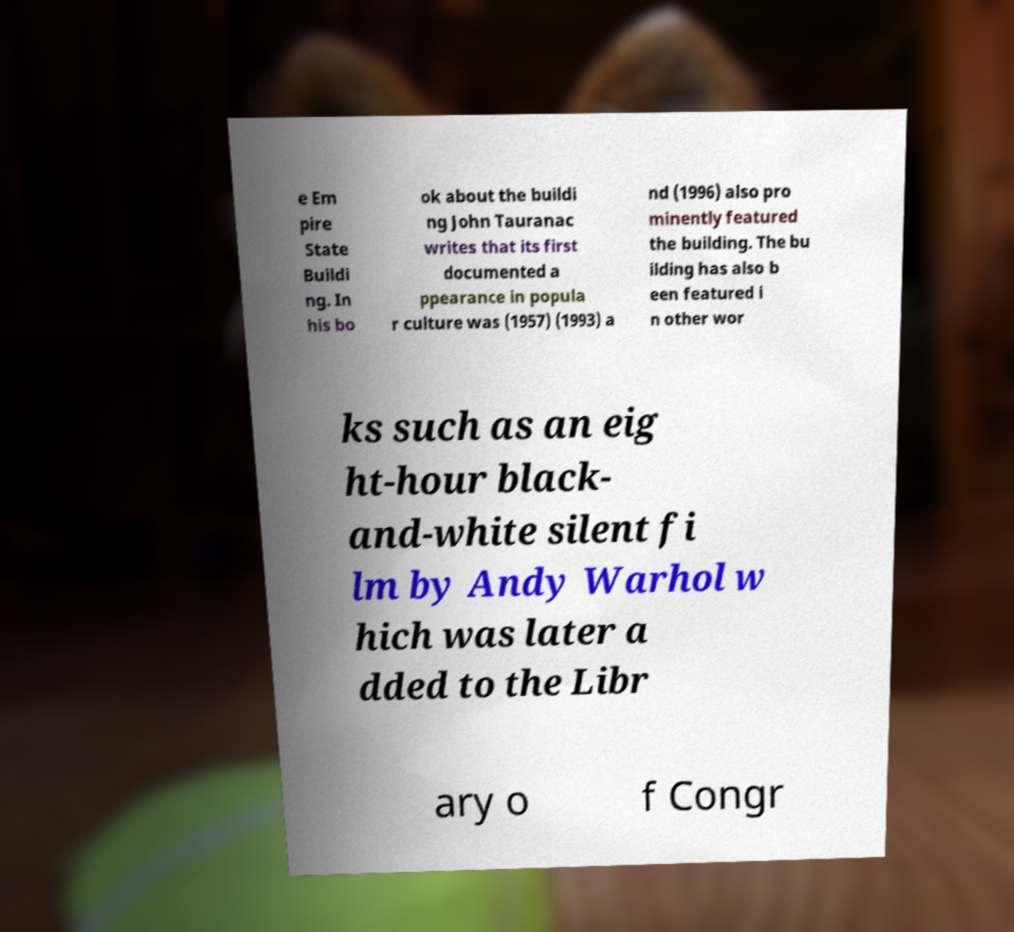Please read and relay the text visible in this image. What does it say? e Em pire State Buildi ng. In his bo ok about the buildi ng John Tauranac writes that its first documented a ppearance in popula r culture was (1957) (1993) a nd (1996) also pro minently featured the building. The bu ilding has also b een featured i n other wor ks such as an eig ht-hour black- and-white silent fi lm by Andy Warhol w hich was later a dded to the Libr ary o f Congr 